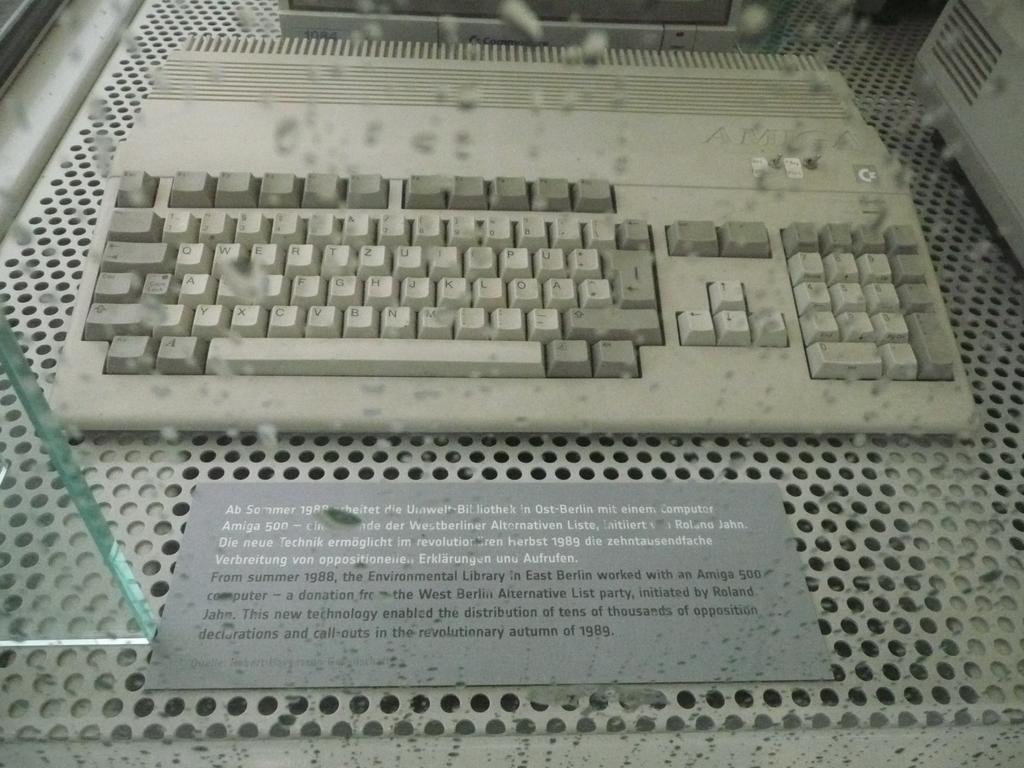What are the dark gray keys along the top of the left side of the keyboard?
Provide a succinct answer. Unanswerable. Is this a usb keyboard?
Make the answer very short. No. 